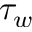Convert formula to latex. <formula><loc_0><loc_0><loc_500><loc_500>\tau _ { w }</formula> 